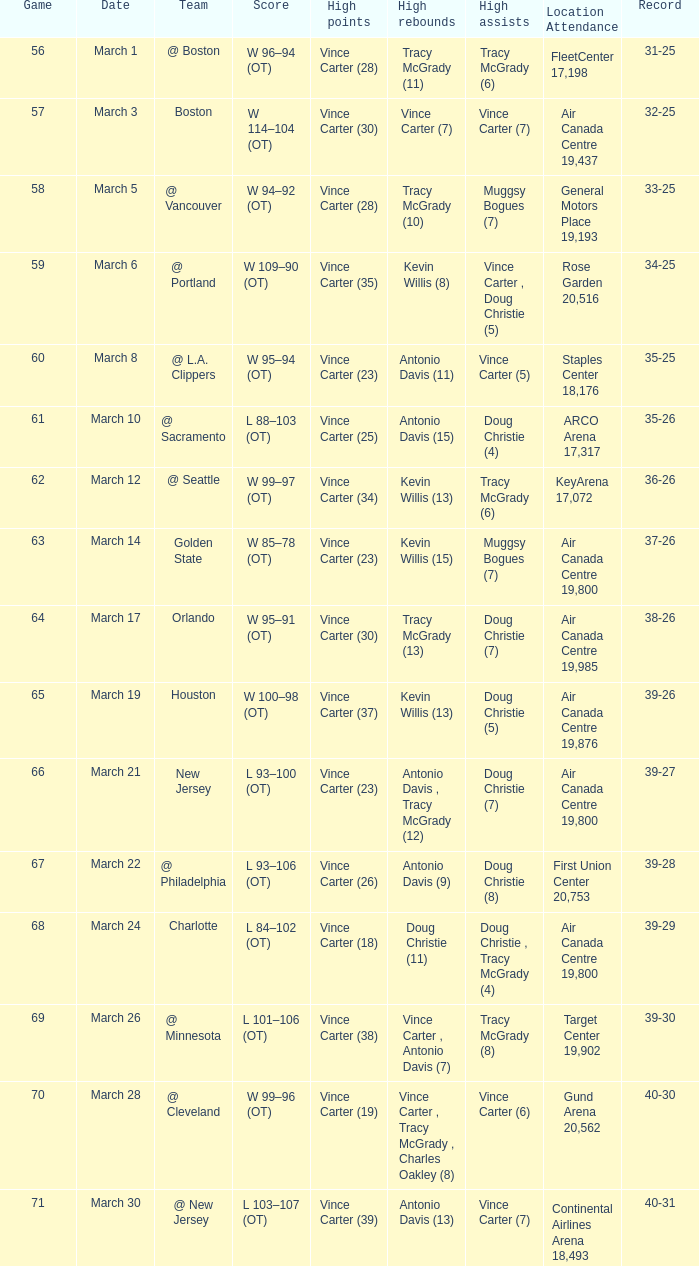How many people had the high assists @ minnesota? 1.0. 